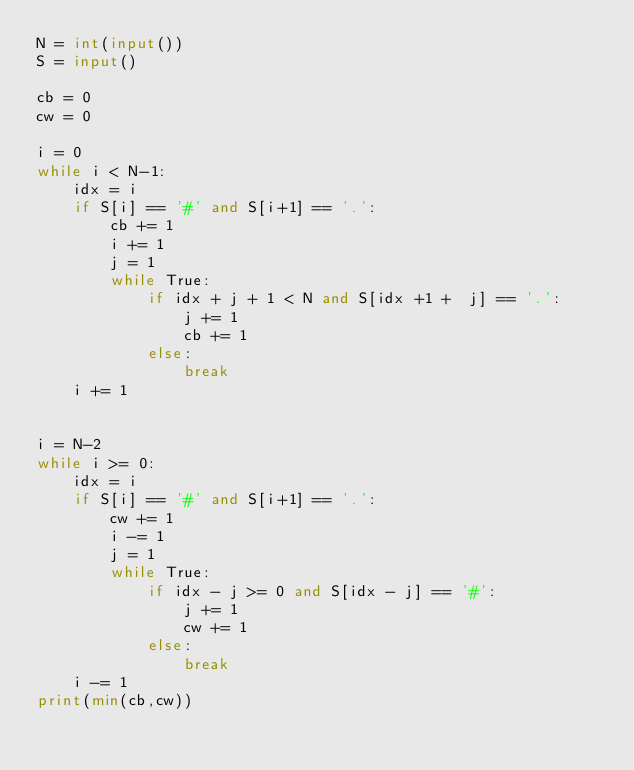<code> <loc_0><loc_0><loc_500><loc_500><_Python_>N = int(input())
S = input()

cb = 0
cw = 0

i = 0
while i < N-1:
    idx = i
    if S[i] == '#' and S[i+1] == '.':
        cb += 1
        i += 1
        j = 1
        while True:
            if idx + j + 1 < N and S[idx +1 +  j] == '.':
                j += 1
                cb += 1
            else:
                break
    i += 1
        
                
i = N-2
while i >= 0:
    idx = i
    if S[i] == '#' and S[i+1] == '.':
        cw += 1
        i -= 1
        j = 1
        while True:
            if idx - j >= 0 and S[idx - j] == '#':
                j += 1
                cw += 1
            else:
                break
    i -= 1
print(min(cb,cw))
                </code> 